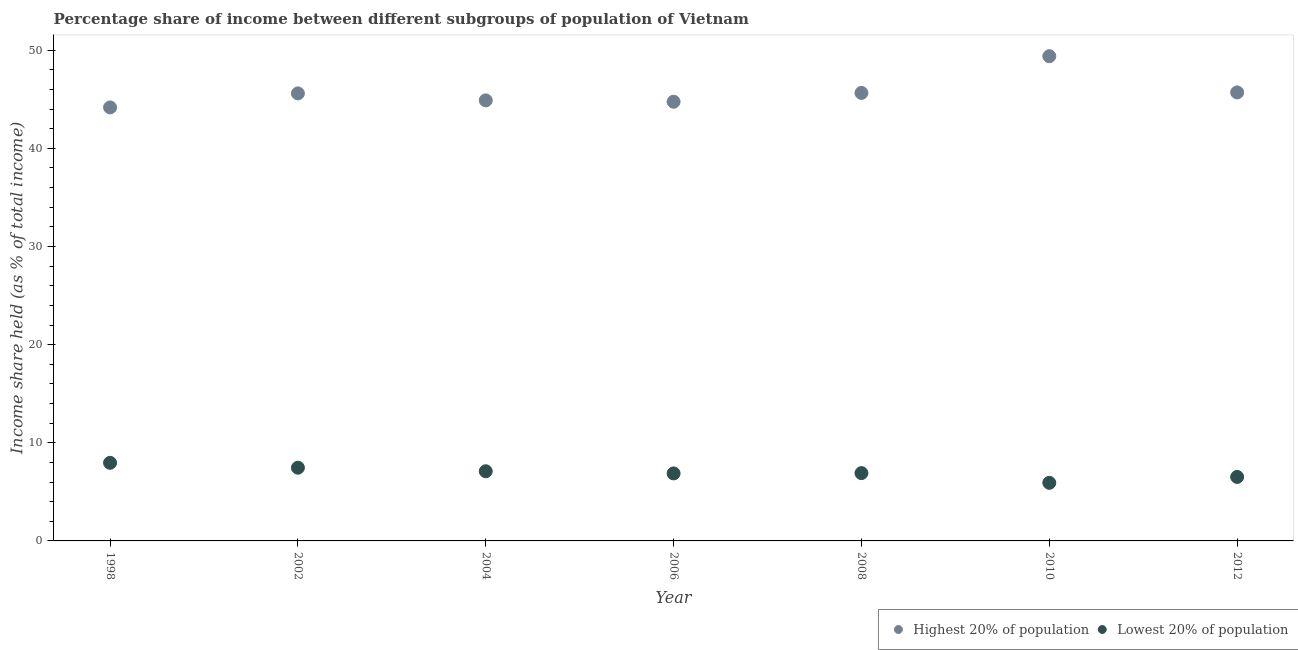How many different coloured dotlines are there?
Keep it short and to the point. 2. Is the number of dotlines equal to the number of legend labels?
Your answer should be compact. Yes. Across all years, what is the maximum income share held by highest 20% of the population?
Offer a terse response. 49.39. Across all years, what is the minimum income share held by lowest 20% of the population?
Offer a very short reply. 5.92. In which year was the income share held by lowest 20% of the population minimum?
Offer a terse response. 2010. What is the total income share held by lowest 20% of the population in the graph?
Make the answer very short. 48.75. What is the difference between the income share held by highest 20% of the population in 2002 and that in 2004?
Your answer should be compact. 0.71. What is the difference between the income share held by highest 20% of the population in 1998 and the income share held by lowest 20% of the population in 2008?
Your response must be concise. 37.26. What is the average income share held by lowest 20% of the population per year?
Your answer should be very brief. 6.96. In the year 2002, what is the difference between the income share held by highest 20% of the population and income share held by lowest 20% of the population?
Your response must be concise. 38.14. In how many years, is the income share held by lowest 20% of the population greater than 48 %?
Ensure brevity in your answer.  0. What is the ratio of the income share held by lowest 20% of the population in 1998 to that in 2004?
Make the answer very short. 1.12. Is the income share held by highest 20% of the population in 1998 less than that in 2010?
Your answer should be very brief. Yes. Is the difference between the income share held by lowest 20% of the population in 1998 and 2004 greater than the difference between the income share held by highest 20% of the population in 1998 and 2004?
Your response must be concise. Yes. What is the difference between the highest and the second highest income share held by highest 20% of the population?
Make the answer very short. 3.69. What is the difference between the highest and the lowest income share held by lowest 20% of the population?
Make the answer very short. 2.04. Is the sum of the income share held by highest 20% of the population in 2004 and 2012 greater than the maximum income share held by lowest 20% of the population across all years?
Ensure brevity in your answer.  Yes. Does the income share held by highest 20% of the population monotonically increase over the years?
Offer a terse response. No. How many years are there in the graph?
Your response must be concise. 7. What is the difference between two consecutive major ticks on the Y-axis?
Offer a terse response. 10. Are the values on the major ticks of Y-axis written in scientific E-notation?
Your answer should be very brief. No. Does the graph contain grids?
Make the answer very short. No. How are the legend labels stacked?
Offer a very short reply. Horizontal. What is the title of the graph?
Offer a very short reply. Percentage share of income between different subgroups of population of Vietnam. Does "Highest 10% of population" appear as one of the legend labels in the graph?
Provide a short and direct response. No. What is the label or title of the X-axis?
Your answer should be compact. Year. What is the label or title of the Y-axis?
Provide a succinct answer. Income share held (as % of total income). What is the Income share held (as % of total income) of Highest 20% of population in 1998?
Make the answer very short. 44.17. What is the Income share held (as % of total income) of Lowest 20% of population in 1998?
Your answer should be very brief. 7.96. What is the Income share held (as % of total income) of Highest 20% of population in 2002?
Make the answer very short. 45.6. What is the Income share held (as % of total income) in Lowest 20% of population in 2002?
Keep it short and to the point. 7.46. What is the Income share held (as % of total income) of Highest 20% of population in 2004?
Your answer should be compact. 44.89. What is the Income share held (as % of total income) in Lowest 20% of population in 2004?
Give a very brief answer. 7.1. What is the Income share held (as % of total income) in Highest 20% of population in 2006?
Keep it short and to the point. 44.75. What is the Income share held (as % of total income) of Lowest 20% of population in 2006?
Your response must be concise. 6.88. What is the Income share held (as % of total income) in Highest 20% of population in 2008?
Make the answer very short. 45.65. What is the Income share held (as % of total income) in Lowest 20% of population in 2008?
Your answer should be compact. 6.91. What is the Income share held (as % of total income) in Highest 20% of population in 2010?
Ensure brevity in your answer.  49.39. What is the Income share held (as % of total income) in Lowest 20% of population in 2010?
Ensure brevity in your answer.  5.92. What is the Income share held (as % of total income) of Highest 20% of population in 2012?
Keep it short and to the point. 45.7. What is the Income share held (as % of total income) in Lowest 20% of population in 2012?
Your answer should be very brief. 6.52. Across all years, what is the maximum Income share held (as % of total income) in Highest 20% of population?
Provide a short and direct response. 49.39. Across all years, what is the maximum Income share held (as % of total income) in Lowest 20% of population?
Your answer should be very brief. 7.96. Across all years, what is the minimum Income share held (as % of total income) in Highest 20% of population?
Your answer should be compact. 44.17. Across all years, what is the minimum Income share held (as % of total income) of Lowest 20% of population?
Provide a succinct answer. 5.92. What is the total Income share held (as % of total income) of Highest 20% of population in the graph?
Your response must be concise. 320.15. What is the total Income share held (as % of total income) of Lowest 20% of population in the graph?
Keep it short and to the point. 48.75. What is the difference between the Income share held (as % of total income) of Highest 20% of population in 1998 and that in 2002?
Your response must be concise. -1.43. What is the difference between the Income share held (as % of total income) of Lowest 20% of population in 1998 and that in 2002?
Provide a short and direct response. 0.5. What is the difference between the Income share held (as % of total income) of Highest 20% of population in 1998 and that in 2004?
Keep it short and to the point. -0.72. What is the difference between the Income share held (as % of total income) of Lowest 20% of population in 1998 and that in 2004?
Make the answer very short. 0.86. What is the difference between the Income share held (as % of total income) in Highest 20% of population in 1998 and that in 2006?
Ensure brevity in your answer.  -0.58. What is the difference between the Income share held (as % of total income) of Highest 20% of population in 1998 and that in 2008?
Make the answer very short. -1.48. What is the difference between the Income share held (as % of total income) of Highest 20% of population in 1998 and that in 2010?
Provide a short and direct response. -5.22. What is the difference between the Income share held (as % of total income) in Lowest 20% of population in 1998 and that in 2010?
Your answer should be very brief. 2.04. What is the difference between the Income share held (as % of total income) in Highest 20% of population in 1998 and that in 2012?
Your response must be concise. -1.53. What is the difference between the Income share held (as % of total income) of Lowest 20% of population in 1998 and that in 2012?
Offer a very short reply. 1.44. What is the difference between the Income share held (as % of total income) of Highest 20% of population in 2002 and that in 2004?
Your answer should be very brief. 0.71. What is the difference between the Income share held (as % of total income) of Lowest 20% of population in 2002 and that in 2004?
Your answer should be very brief. 0.36. What is the difference between the Income share held (as % of total income) in Highest 20% of population in 2002 and that in 2006?
Keep it short and to the point. 0.85. What is the difference between the Income share held (as % of total income) in Lowest 20% of population in 2002 and that in 2006?
Give a very brief answer. 0.58. What is the difference between the Income share held (as % of total income) in Highest 20% of population in 2002 and that in 2008?
Provide a short and direct response. -0.05. What is the difference between the Income share held (as % of total income) in Lowest 20% of population in 2002 and that in 2008?
Offer a terse response. 0.55. What is the difference between the Income share held (as % of total income) of Highest 20% of population in 2002 and that in 2010?
Ensure brevity in your answer.  -3.79. What is the difference between the Income share held (as % of total income) of Lowest 20% of population in 2002 and that in 2010?
Ensure brevity in your answer.  1.54. What is the difference between the Income share held (as % of total income) of Highest 20% of population in 2002 and that in 2012?
Ensure brevity in your answer.  -0.1. What is the difference between the Income share held (as % of total income) in Highest 20% of population in 2004 and that in 2006?
Your response must be concise. 0.14. What is the difference between the Income share held (as % of total income) of Lowest 20% of population in 2004 and that in 2006?
Ensure brevity in your answer.  0.22. What is the difference between the Income share held (as % of total income) in Highest 20% of population in 2004 and that in 2008?
Keep it short and to the point. -0.76. What is the difference between the Income share held (as % of total income) of Lowest 20% of population in 2004 and that in 2008?
Your answer should be compact. 0.19. What is the difference between the Income share held (as % of total income) in Lowest 20% of population in 2004 and that in 2010?
Provide a short and direct response. 1.18. What is the difference between the Income share held (as % of total income) of Highest 20% of population in 2004 and that in 2012?
Provide a succinct answer. -0.81. What is the difference between the Income share held (as % of total income) of Lowest 20% of population in 2004 and that in 2012?
Provide a succinct answer. 0.58. What is the difference between the Income share held (as % of total income) of Highest 20% of population in 2006 and that in 2008?
Provide a short and direct response. -0.9. What is the difference between the Income share held (as % of total income) in Lowest 20% of population in 2006 and that in 2008?
Your answer should be compact. -0.03. What is the difference between the Income share held (as % of total income) in Highest 20% of population in 2006 and that in 2010?
Keep it short and to the point. -4.64. What is the difference between the Income share held (as % of total income) of Highest 20% of population in 2006 and that in 2012?
Provide a succinct answer. -0.95. What is the difference between the Income share held (as % of total income) in Lowest 20% of population in 2006 and that in 2012?
Make the answer very short. 0.36. What is the difference between the Income share held (as % of total income) of Highest 20% of population in 2008 and that in 2010?
Offer a very short reply. -3.74. What is the difference between the Income share held (as % of total income) of Lowest 20% of population in 2008 and that in 2012?
Provide a succinct answer. 0.39. What is the difference between the Income share held (as % of total income) in Highest 20% of population in 2010 and that in 2012?
Make the answer very short. 3.69. What is the difference between the Income share held (as % of total income) in Highest 20% of population in 1998 and the Income share held (as % of total income) in Lowest 20% of population in 2002?
Make the answer very short. 36.71. What is the difference between the Income share held (as % of total income) of Highest 20% of population in 1998 and the Income share held (as % of total income) of Lowest 20% of population in 2004?
Keep it short and to the point. 37.07. What is the difference between the Income share held (as % of total income) of Highest 20% of population in 1998 and the Income share held (as % of total income) of Lowest 20% of population in 2006?
Keep it short and to the point. 37.29. What is the difference between the Income share held (as % of total income) of Highest 20% of population in 1998 and the Income share held (as % of total income) of Lowest 20% of population in 2008?
Ensure brevity in your answer.  37.26. What is the difference between the Income share held (as % of total income) in Highest 20% of population in 1998 and the Income share held (as % of total income) in Lowest 20% of population in 2010?
Your answer should be compact. 38.25. What is the difference between the Income share held (as % of total income) of Highest 20% of population in 1998 and the Income share held (as % of total income) of Lowest 20% of population in 2012?
Your response must be concise. 37.65. What is the difference between the Income share held (as % of total income) in Highest 20% of population in 2002 and the Income share held (as % of total income) in Lowest 20% of population in 2004?
Offer a very short reply. 38.5. What is the difference between the Income share held (as % of total income) in Highest 20% of population in 2002 and the Income share held (as % of total income) in Lowest 20% of population in 2006?
Your answer should be compact. 38.72. What is the difference between the Income share held (as % of total income) of Highest 20% of population in 2002 and the Income share held (as % of total income) of Lowest 20% of population in 2008?
Offer a very short reply. 38.69. What is the difference between the Income share held (as % of total income) of Highest 20% of population in 2002 and the Income share held (as % of total income) of Lowest 20% of population in 2010?
Provide a short and direct response. 39.68. What is the difference between the Income share held (as % of total income) of Highest 20% of population in 2002 and the Income share held (as % of total income) of Lowest 20% of population in 2012?
Offer a very short reply. 39.08. What is the difference between the Income share held (as % of total income) in Highest 20% of population in 2004 and the Income share held (as % of total income) in Lowest 20% of population in 2006?
Your answer should be very brief. 38.01. What is the difference between the Income share held (as % of total income) in Highest 20% of population in 2004 and the Income share held (as % of total income) in Lowest 20% of population in 2008?
Offer a very short reply. 37.98. What is the difference between the Income share held (as % of total income) in Highest 20% of population in 2004 and the Income share held (as % of total income) in Lowest 20% of population in 2010?
Provide a succinct answer. 38.97. What is the difference between the Income share held (as % of total income) in Highest 20% of population in 2004 and the Income share held (as % of total income) in Lowest 20% of population in 2012?
Your answer should be very brief. 38.37. What is the difference between the Income share held (as % of total income) of Highest 20% of population in 2006 and the Income share held (as % of total income) of Lowest 20% of population in 2008?
Offer a very short reply. 37.84. What is the difference between the Income share held (as % of total income) of Highest 20% of population in 2006 and the Income share held (as % of total income) of Lowest 20% of population in 2010?
Your answer should be very brief. 38.83. What is the difference between the Income share held (as % of total income) in Highest 20% of population in 2006 and the Income share held (as % of total income) in Lowest 20% of population in 2012?
Your answer should be very brief. 38.23. What is the difference between the Income share held (as % of total income) in Highest 20% of population in 2008 and the Income share held (as % of total income) in Lowest 20% of population in 2010?
Make the answer very short. 39.73. What is the difference between the Income share held (as % of total income) of Highest 20% of population in 2008 and the Income share held (as % of total income) of Lowest 20% of population in 2012?
Keep it short and to the point. 39.13. What is the difference between the Income share held (as % of total income) in Highest 20% of population in 2010 and the Income share held (as % of total income) in Lowest 20% of population in 2012?
Give a very brief answer. 42.87. What is the average Income share held (as % of total income) in Highest 20% of population per year?
Provide a short and direct response. 45.74. What is the average Income share held (as % of total income) in Lowest 20% of population per year?
Provide a succinct answer. 6.96. In the year 1998, what is the difference between the Income share held (as % of total income) in Highest 20% of population and Income share held (as % of total income) in Lowest 20% of population?
Offer a terse response. 36.21. In the year 2002, what is the difference between the Income share held (as % of total income) in Highest 20% of population and Income share held (as % of total income) in Lowest 20% of population?
Offer a terse response. 38.14. In the year 2004, what is the difference between the Income share held (as % of total income) of Highest 20% of population and Income share held (as % of total income) of Lowest 20% of population?
Keep it short and to the point. 37.79. In the year 2006, what is the difference between the Income share held (as % of total income) of Highest 20% of population and Income share held (as % of total income) of Lowest 20% of population?
Provide a succinct answer. 37.87. In the year 2008, what is the difference between the Income share held (as % of total income) in Highest 20% of population and Income share held (as % of total income) in Lowest 20% of population?
Keep it short and to the point. 38.74. In the year 2010, what is the difference between the Income share held (as % of total income) of Highest 20% of population and Income share held (as % of total income) of Lowest 20% of population?
Give a very brief answer. 43.47. In the year 2012, what is the difference between the Income share held (as % of total income) of Highest 20% of population and Income share held (as % of total income) of Lowest 20% of population?
Offer a terse response. 39.18. What is the ratio of the Income share held (as % of total income) of Highest 20% of population in 1998 to that in 2002?
Provide a succinct answer. 0.97. What is the ratio of the Income share held (as % of total income) of Lowest 20% of population in 1998 to that in 2002?
Offer a very short reply. 1.07. What is the ratio of the Income share held (as % of total income) of Highest 20% of population in 1998 to that in 2004?
Give a very brief answer. 0.98. What is the ratio of the Income share held (as % of total income) of Lowest 20% of population in 1998 to that in 2004?
Offer a terse response. 1.12. What is the ratio of the Income share held (as % of total income) in Highest 20% of population in 1998 to that in 2006?
Your answer should be very brief. 0.99. What is the ratio of the Income share held (as % of total income) in Lowest 20% of population in 1998 to that in 2006?
Your answer should be very brief. 1.16. What is the ratio of the Income share held (as % of total income) in Highest 20% of population in 1998 to that in 2008?
Offer a terse response. 0.97. What is the ratio of the Income share held (as % of total income) of Lowest 20% of population in 1998 to that in 2008?
Provide a succinct answer. 1.15. What is the ratio of the Income share held (as % of total income) in Highest 20% of population in 1998 to that in 2010?
Your answer should be compact. 0.89. What is the ratio of the Income share held (as % of total income) in Lowest 20% of population in 1998 to that in 2010?
Make the answer very short. 1.34. What is the ratio of the Income share held (as % of total income) of Highest 20% of population in 1998 to that in 2012?
Your answer should be very brief. 0.97. What is the ratio of the Income share held (as % of total income) in Lowest 20% of population in 1998 to that in 2012?
Give a very brief answer. 1.22. What is the ratio of the Income share held (as % of total income) of Highest 20% of population in 2002 to that in 2004?
Ensure brevity in your answer.  1.02. What is the ratio of the Income share held (as % of total income) of Lowest 20% of population in 2002 to that in 2004?
Provide a succinct answer. 1.05. What is the ratio of the Income share held (as % of total income) in Lowest 20% of population in 2002 to that in 2006?
Your answer should be very brief. 1.08. What is the ratio of the Income share held (as % of total income) of Highest 20% of population in 2002 to that in 2008?
Provide a short and direct response. 1. What is the ratio of the Income share held (as % of total income) of Lowest 20% of population in 2002 to that in 2008?
Your response must be concise. 1.08. What is the ratio of the Income share held (as % of total income) of Highest 20% of population in 2002 to that in 2010?
Give a very brief answer. 0.92. What is the ratio of the Income share held (as % of total income) of Lowest 20% of population in 2002 to that in 2010?
Your answer should be compact. 1.26. What is the ratio of the Income share held (as % of total income) in Highest 20% of population in 2002 to that in 2012?
Ensure brevity in your answer.  1. What is the ratio of the Income share held (as % of total income) of Lowest 20% of population in 2002 to that in 2012?
Offer a terse response. 1.14. What is the ratio of the Income share held (as % of total income) in Highest 20% of population in 2004 to that in 2006?
Provide a succinct answer. 1. What is the ratio of the Income share held (as % of total income) in Lowest 20% of population in 2004 to that in 2006?
Provide a short and direct response. 1.03. What is the ratio of the Income share held (as % of total income) of Highest 20% of population in 2004 to that in 2008?
Ensure brevity in your answer.  0.98. What is the ratio of the Income share held (as % of total income) of Lowest 20% of population in 2004 to that in 2008?
Give a very brief answer. 1.03. What is the ratio of the Income share held (as % of total income) in Highest 20% of population in 2004 to that in 2010?
Your response must be concise. 0.91. What is the ratio of the Income share held (as % of total income) in Lowest 20% of population in 2004 to that in 2010?
Provide a succinct answer. 1.2. What is the ratio of the Income share held (as % of total income) of Highest 20% of population in 2004 to that in 2012?
Provide a short and direct response. 0.98. What is the ratio of the Income share held (as % of total income) of Lowest 20% of population in 2004 to that in 2012?
Ensure brevity in your answer.  1.09. What is the ratio of the Income share held (as % of total income) of Highest 20% of population in 2006 to that in 2008?
Make the answer very short. 0.98. What is the ratio of the Income share held (as % of total income) in Lowest 20% of population in 2006 to that in 2008?
Provide a succinct answer. 1. What is the ratio of the Income share held (as % of total income) in Highest 20% of population in 2006 to that in 2010?
Keep it short and to the point. 0.91. What is the ratio of the Income share held (as % of total income) in Lowest 20% of population in 2006 to that in 2010?
Make the answer very short. 1.16. What is the ratio of the Income share held (as % of total income) in Highest 20% of population in 2006 to that in 2012?
Make the answer very short. 0.98. What is the ratio of the Income share held (as % of total income) in Lowest 20% of population in 2006 to that in 2012?
Offer a terse response. 1.06. What is the ratio of the Income share held (as % of total income) in Highest 20% of population in 2008 to that in 2010?
Your response must be concise. 0.92. What is the ratio of the Income share held (as % of total income) in Lowest 20% of population in 2008 to that in 2010?
Offer a terse response. 1.17. What is the ratio of the Income share held (as % of total income) of Lowest 20% of population in 2008 to that in 2012?
Offer a terse response. 1.06. What is the ratio of the Income share held (as % of total income) in Highest 20% of population in 2010 to that in 2012?
Offer a very short reply. 1.08. What is the ratio of the Income share held (as % of total income) in Lowest 20% of population in 2010 to that in 2012?
Keep it short and to the point. 0.91. What is the difference between the highest and the second highest Income share held (as % of total income) of Highest 20% of population?
Your answer should be very brief. 3.69. What is the difference between the highest and the second highest Income share held (as % of total income) of Lowest 20% of population?
Keep it short and to the point. 0.5. What is the difference between the highest and the lowest Income share held (as % of total income) in Highest 20% of population?
Your answer should be very brief. 5.22. What is the difference between the highest and the lowest Income share held (as % of total income) of Lowest 20% of population?
Keep it short and to the point. 2.04. 